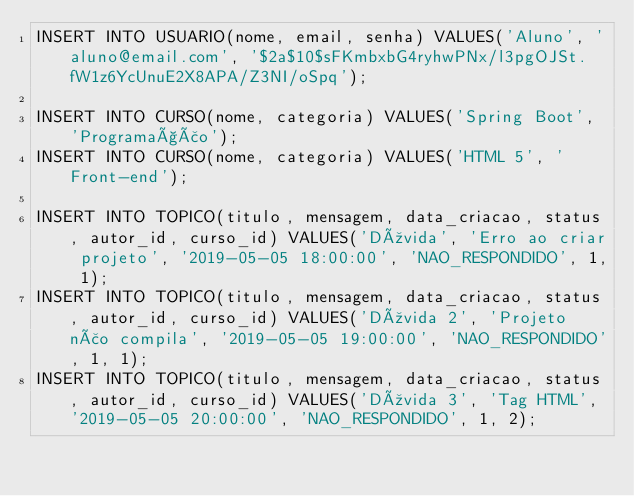<code> <loc_0><loc_0><loc_500><loc_500><_SQL_>INSERT INTO USUARIO(nome, email, senha) VALUES('Aluno', 'aluno@email.com', '$2a$10$sFKmbxbG4ryhwPNx/l3pgOJSt.fW1z6YcUnuE2X8APA/Z3NI/oSpq');

INSERT INTO CURSO(nome, categoria) VALUES('Spring Boot', 'Programação');
INSERT INTO CURSO(nome, categoria) VALUES('HTML 5', 'Front-end');

INSERT INTO TOPICO(titulo, mensagem, data_criacao, status, autor_id, curso_id) VALUES('Dúvida', 'Erro ao criar projeto', '2019-05-05 18:00:00', 'NAO_RESPONDIDO', 1, 1);
INSERT INTO TOPICO(titulo, mensagem, data_criacao, status, autor_id, curso_id) VALUES('Dúvida 2', 'Projeto não compila', '2019-05-05 19:00:00', 'NAO_RESPONDIDO', 1, 1);
INSERT INTO TOPICO(titulo, mensagem, data_criacao, status, autor_id, curso_id) VALUES('Dúvida 3', 'Tag HTML', '2019-05-05 20:00:00', 'NAO_RESPONDIDO', 1, 2);
</code> 